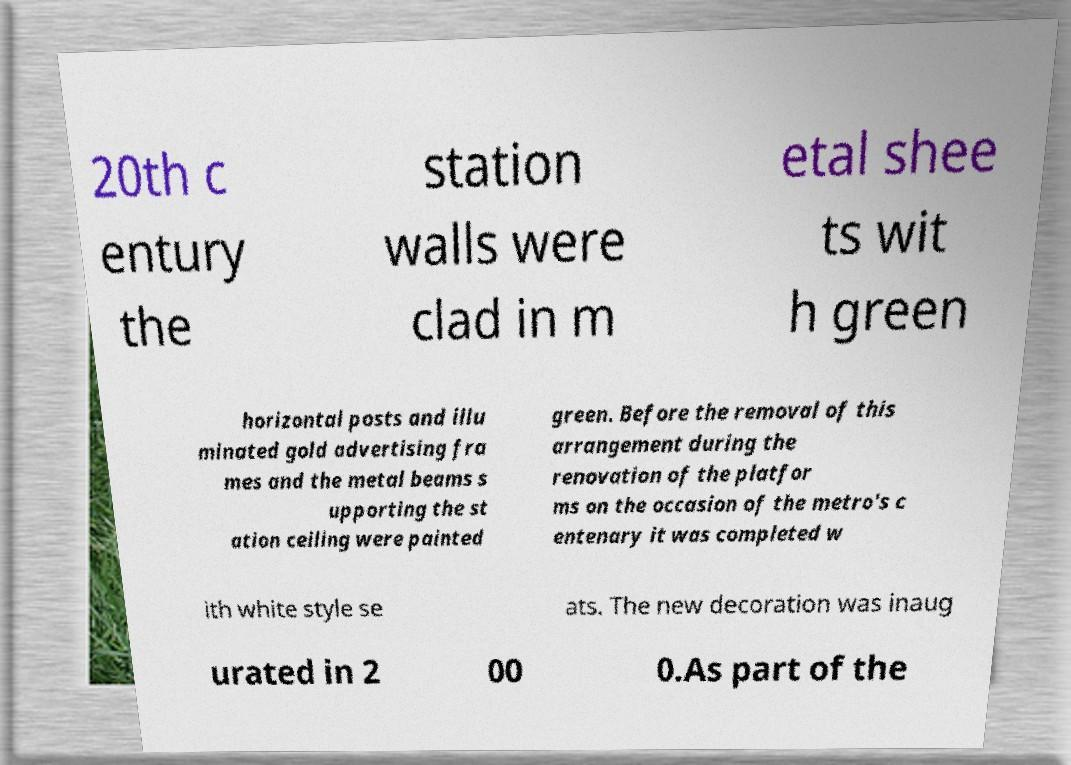I need the written content from this picture converted into text. Can you do that? 20th c entury the station walls were clad in m etal shee ts wit h green horizontal posts and illu minated gold advertising fra mes and the metal beams s upporting the st ation ceiling were painted green. Before the removal of this arrangement during the renovation of the platfor ms on the occasion of the metro's c entenary it was completed w ith white style se ats. The new decoration was inaug urated in 2 00 0.As part of the 